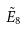Convert formula to latex. <formula><loc_0><loc_0><loc_500><loc_500>\tilde { E } _ { 8 }</formula> 